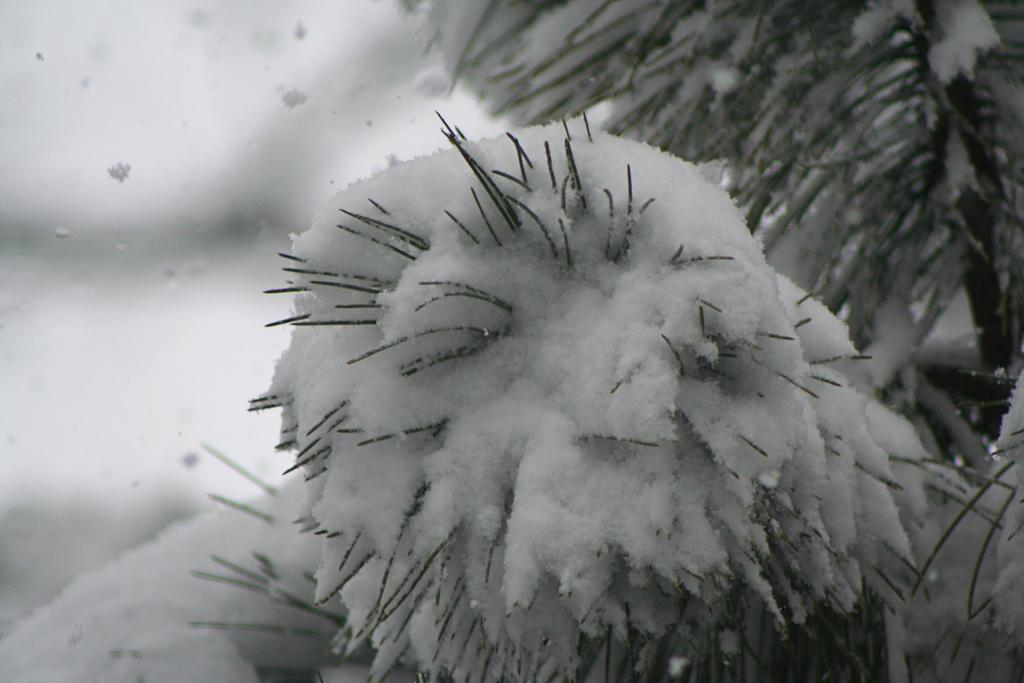Where was the image taken? The image was taken outdoors. What can be seen in the image besides the outdoor setting? There is a plant in the image. How is the plant affected by the outdoor conditions? The plant is covered with snow. On which side of the image is the plant located? The plant is on the right side of the image. What caption is written on the plant in the image? There is no caption written on the plant in the image. How many passengers are visible in the image? There are no passengers present in the image. 